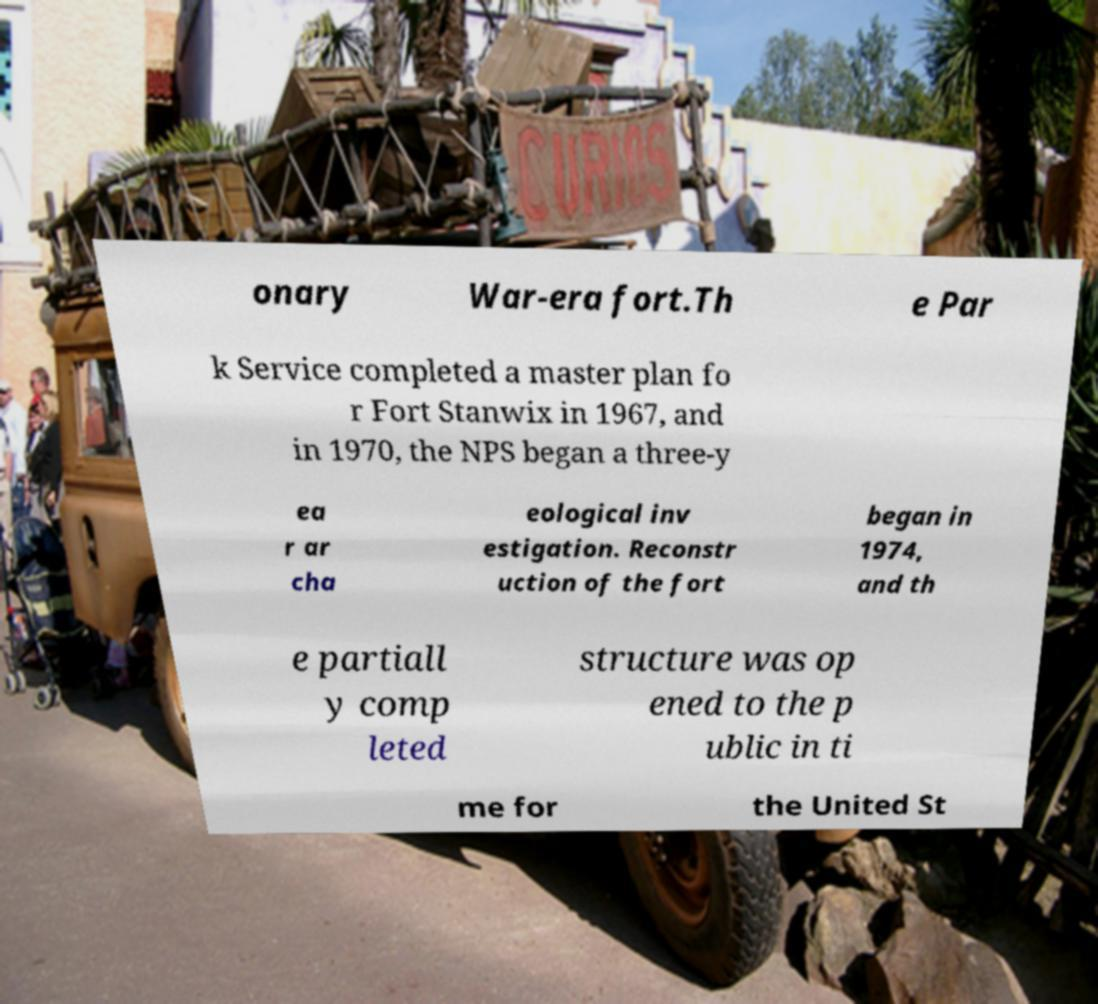Could you extract and type out the text from this image? onary War-era fort.Th e Par k Service completed a master plan fo r Fort Stanwix in 1967, and in 1970, the NPS began a three-y ea r ar cha eological inv estigation. Reconstr uction of the fort began in 1974, and th e partiall y comp leted structure was op ened to the p ublic in ti me for the United St 